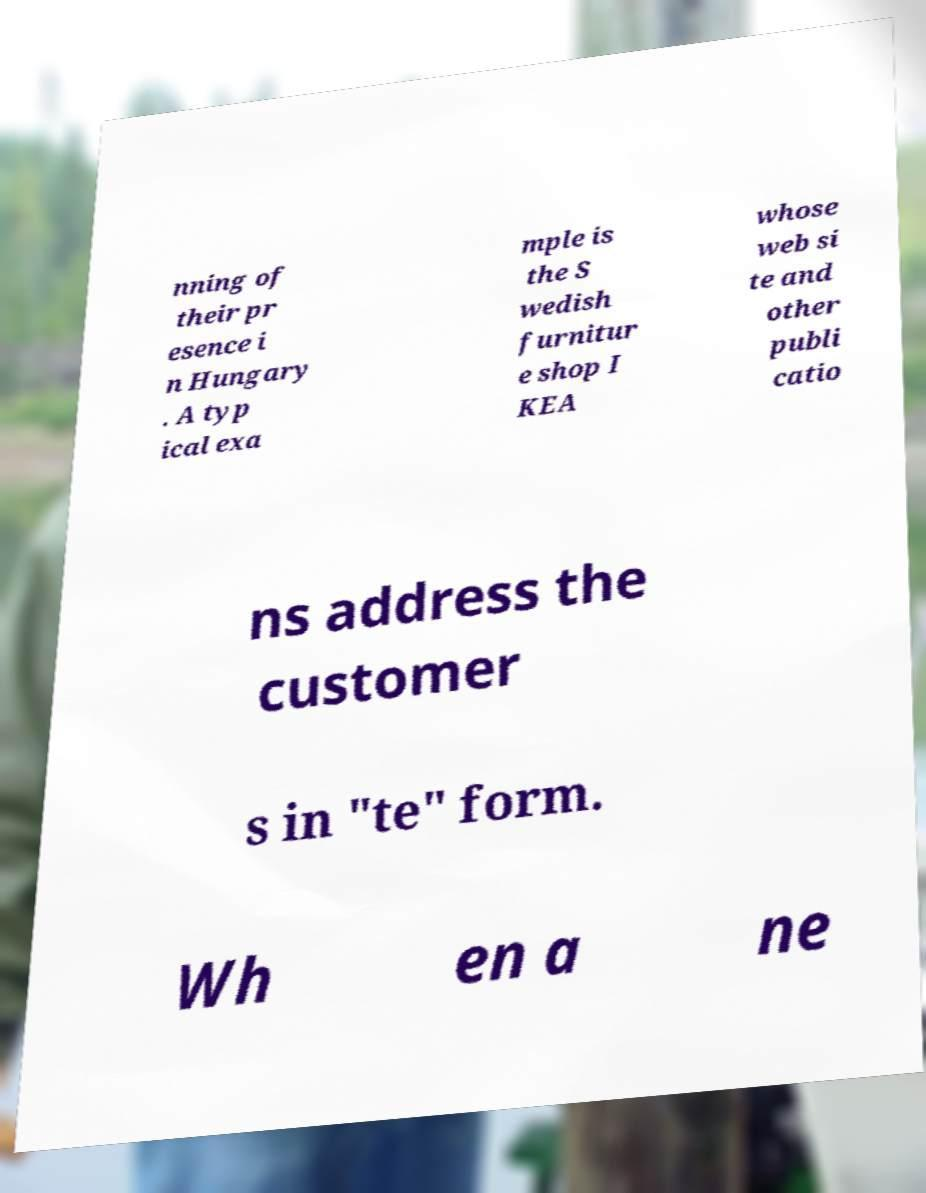For documentation purposes, I need the text within this image transcribed. Could you provide that? nning of their pr esence i n Hungary . A typ ical exa mple is the S wedish furnitur e shop I KEA whose web si te and other publi catio ns address the customer s in "te" form. Wh en a ne 